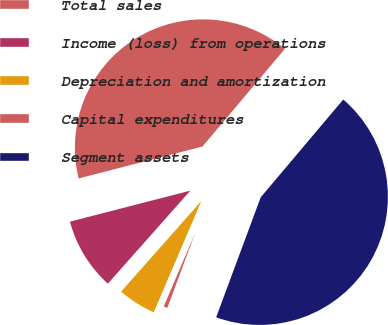Convert chart. <chart><loc_0><loc_0><loc_500><loc_500><pie_chart><fcel>Total sales<fcel>Income (loss) from operations<fcel>Depreciation and amortization<fcel>Capital expenditures<fcel>Segment assets<nl><fcel>40.18%<fcel>9.44%<fcel>5.11%<fcel>0.78%<fcel>44.51%<nl></chart> 